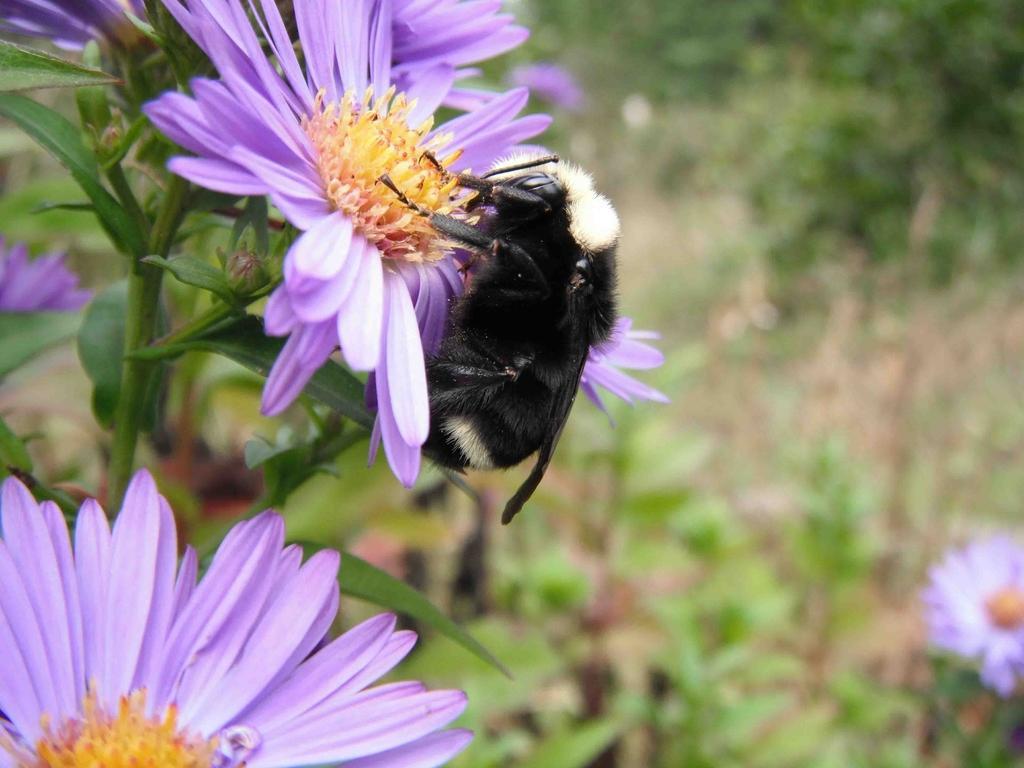Could you give a brief overview of what you see in this image? In this image we can see an insect, plants, and flowers. There is a blur background. 